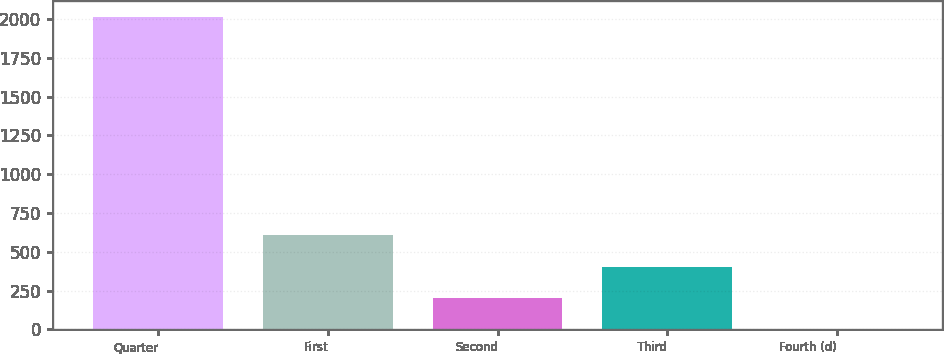Convert chart to OTSL. <chart><loc_0><loc_0><loc_500><loc_500><bar_chart><fcel>Quarter<fcel>First<fcel>Second<fcel>Third<fcel>Fourth (d)<nl><fcel>2015<fcel>605.19<fcel>202.39<fcel>403.79<fcel>0.99<nl></chart> 